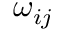<formula> <loc_0><loc_0><loc_500><loc_500>\omega _ { i j }</formula> 